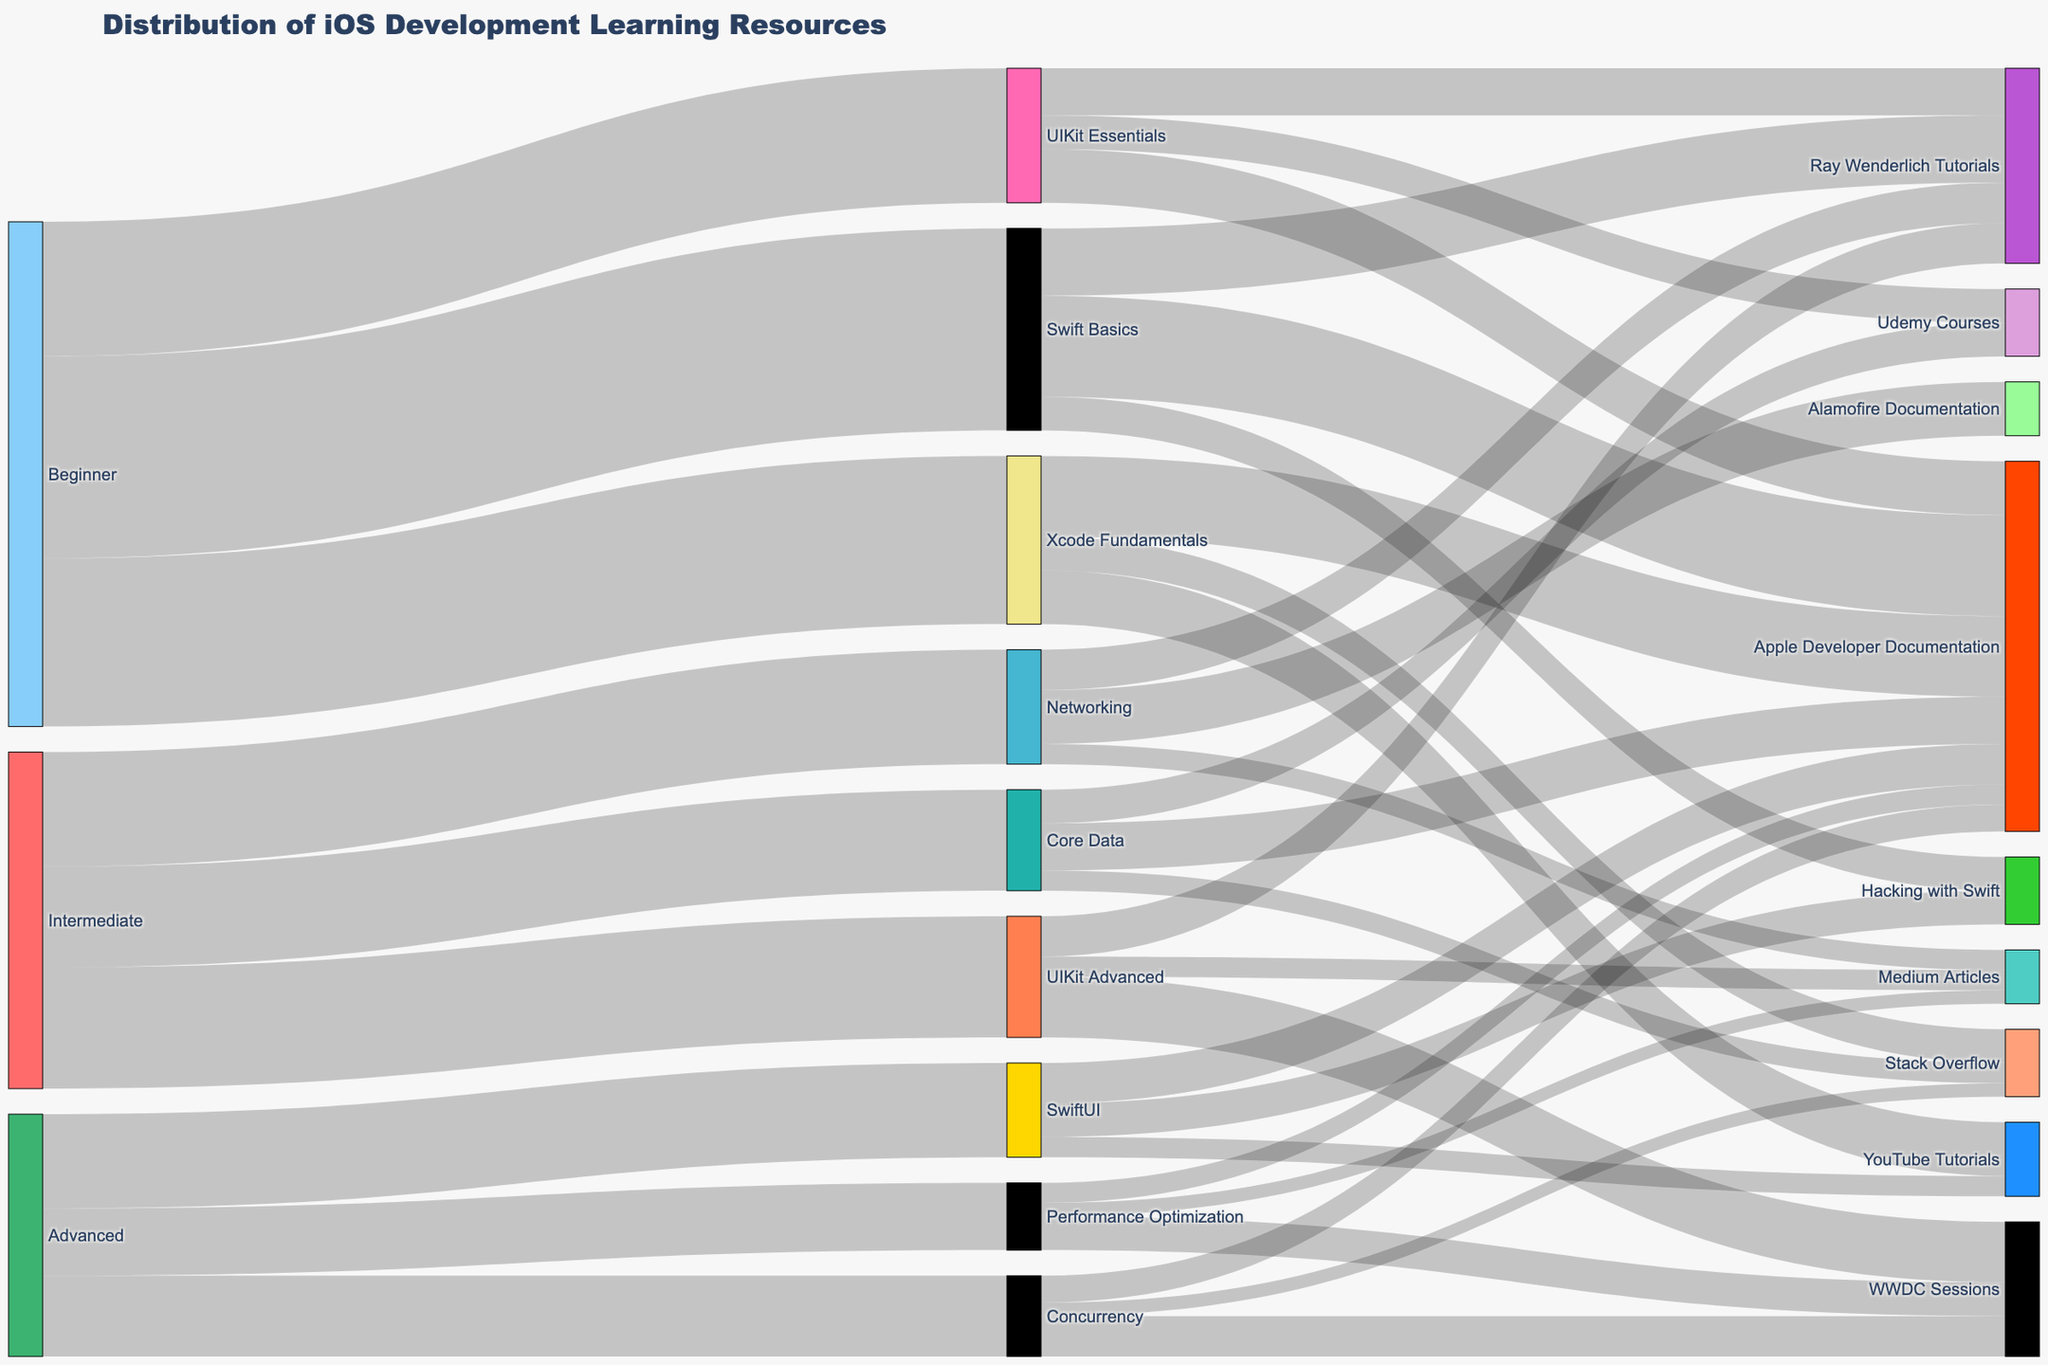What is the title of the Sankey diagram? The title is located at the top of the figure and describes the main subject of the diagram.
Answer: Distribution of iOS Development Learning Resources What skill level accesses Apple Developer Documentation for UIKit Essentials? Trace the flow from 'UIKit Essentials' to its learning resources, including Apple Developer Documentation.
Answer: Beginner Which skill level has the highest number of resources accessed for Swift Basics? Compare the values for the 'Swift Basics' target coming from different skill levels to see which one adds up to the highest number.
Answer: Beginner How many resources are accessed for Networking from Intermediate? Identify the flow from 'Intermediate' to 'Networking' and check its value.
Answer: 170 What is the total number of resources accessed by Advanced skill level? Add the values for all targets that have 'Advanced' as a source: SwiftUI (140), Concurrency (120), Performance Optimization (100).
Answer: 360 Compare the number of resources accessed for Performance Optimization and Concurrency at Advanced level. Which is greater? Check the values leading from 'Advanced' to 'Performance Optimization' and 'Concurrency'. Performance Optimization has 100, Concurrency has 120.
Answer: Concurrency What proportion of Swift Basics resources are gained from Hacking with Swift tutorials compared to the total Swift Basics resources? Calculate the proportion: (Hacking with Swift: 50)/(Total Swift Basics: 300).
Answer: 1/6 Which resource is the most accessed by Beginners? Examine the values from 'Beginner' to all its targets and find the highest one. Swift Basics has the highest value with 300.
Answer: Swift Basics What resource is primarily accessed for learning Core Data? Identify the target with the highest value coming from 'Core Data'. In this case, Apple Developer Documentation, with 70.
Answer: Apple Developer Documentation What is the difference in the number of resources accessed for Xcode Fundamentals and UIKit Essentials by Beginners? Subtract the value of resources for UIKit Essentials (200) from Xcode Fundamentals (250).
Answer: 50 